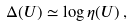<formula> <loc_0><loc_0><loc_500><loc_500>\Delta ( U ) \simeq \log \eta ( U ) \, ,</formula> 